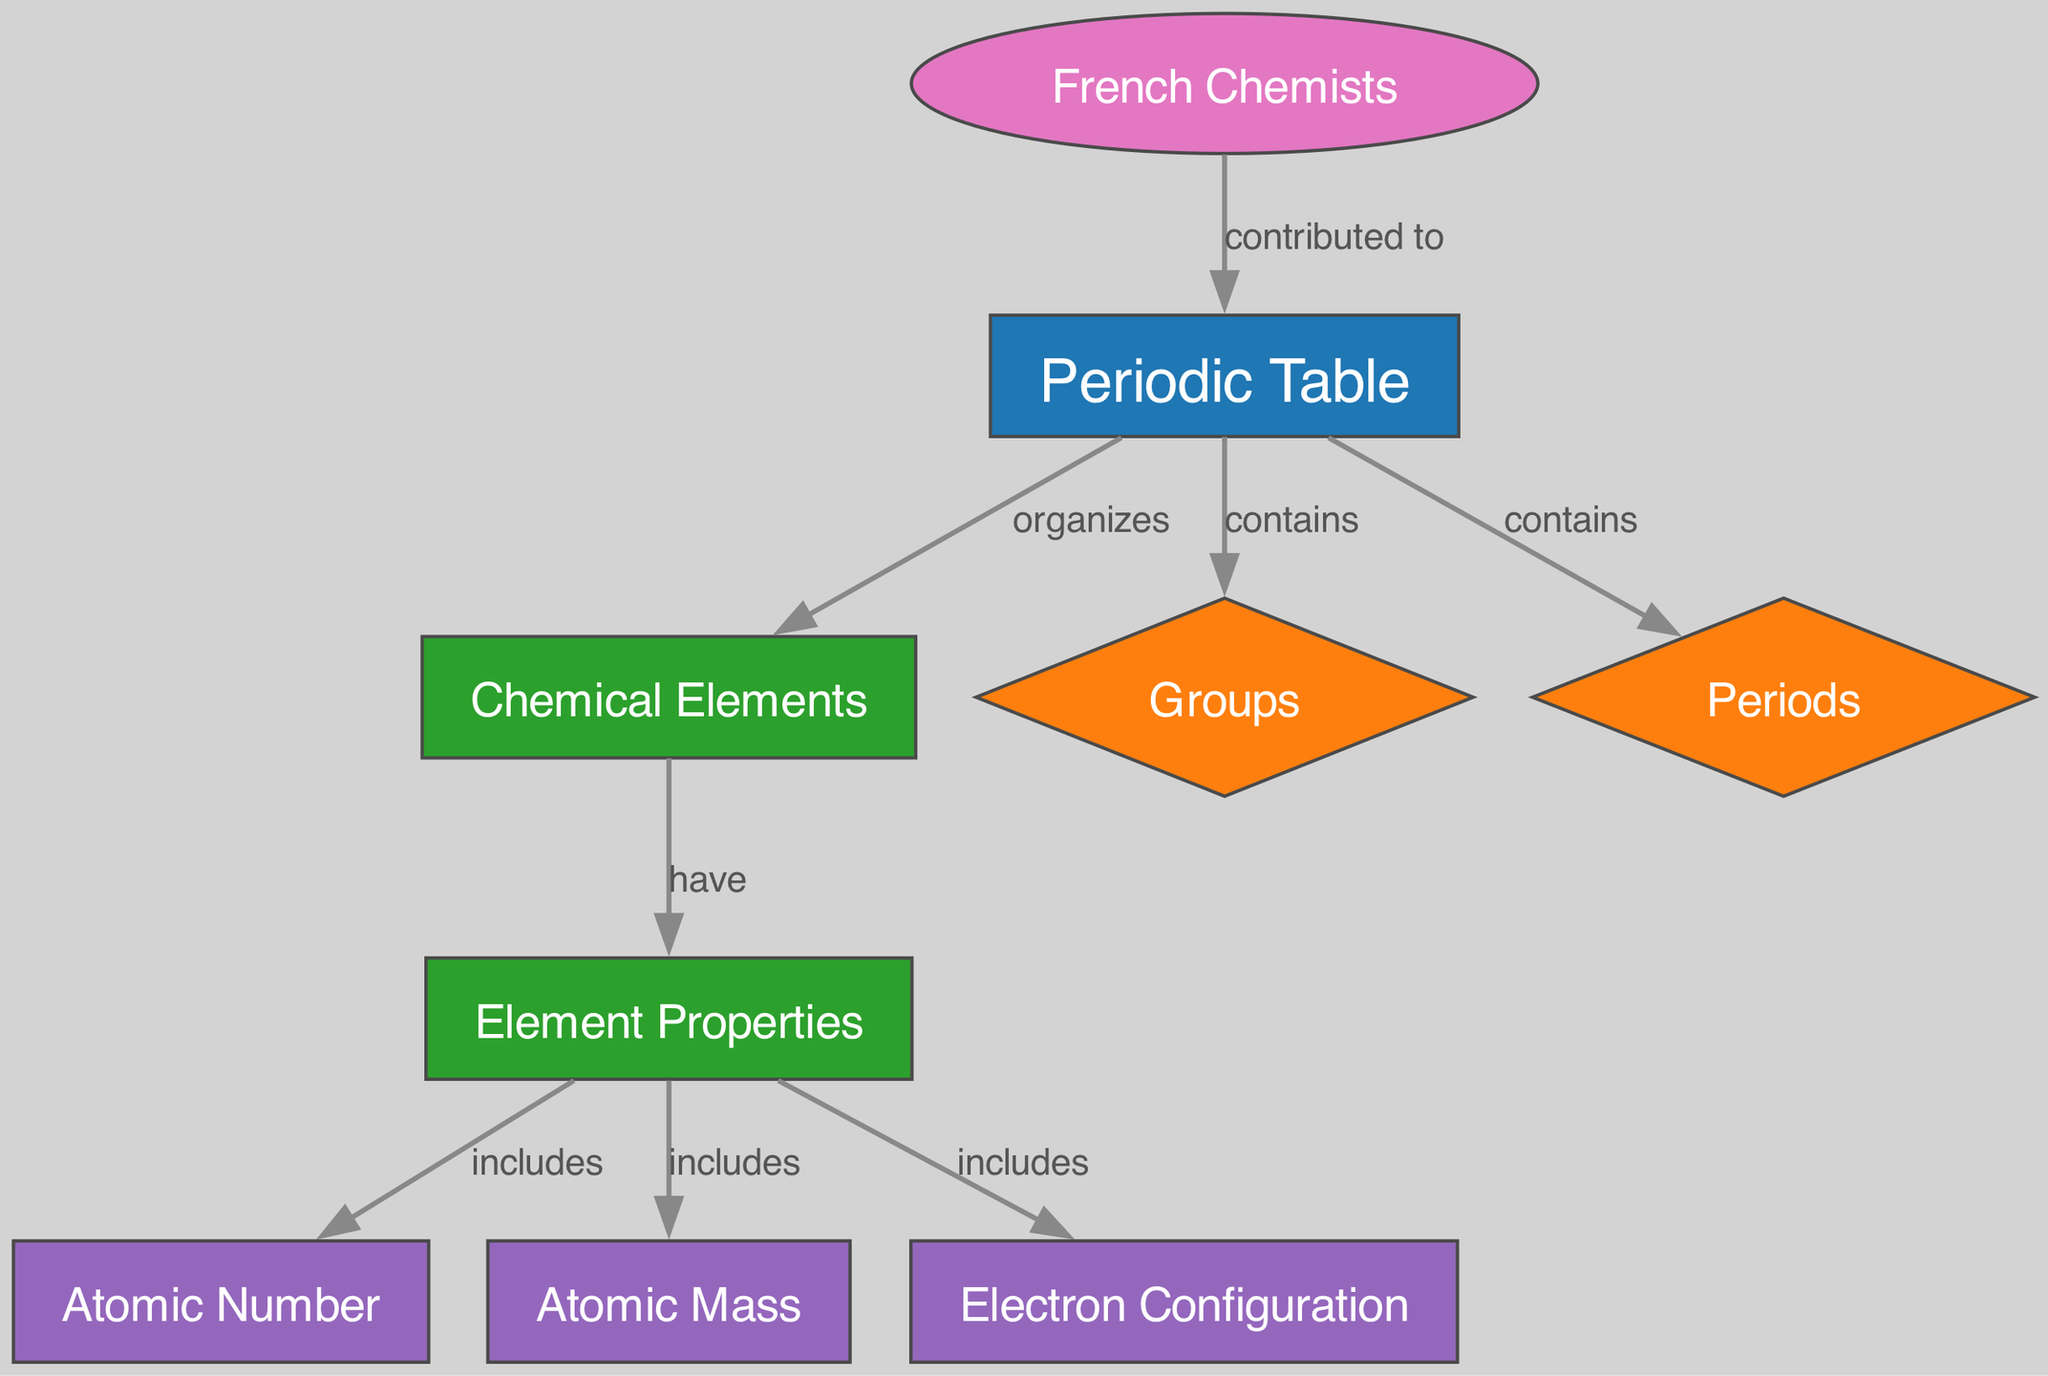What does the periodic table organize? The diagram indicates that the periodic table organizes chemical elements. The relationship is explicitly stated in the edge connecting "periodic_table" to "elements" labeled "organizes."
Answer: chemical elements What types of groups does the periodic table contain? The periodic table contains groups, as mentioned in the edge labeled "contains" connecting "periodic_table" to "groups." This confirms that groups are a category present in the periodic table.
Answer: groups What are three properties included under element properties? The properties include atomic number, atomic mass, and electron configuration. This is derived from the edges connecting "properties" to each of these three attributes labeled "includes."
Answer: atomic number, atomic mass, electron configuration Who contributed to the development of the periodic table? French chemists contributed to the periodic table, as indicated by the edge connecting "french_chemists" to "periodic_table," labeled "contributed to."
Answer: French chemists What is the relationship between elements and properties? The relationship is that elements have properties, as indicated by the edge connecting "elements" to "properties" labeled "have." This shows the fundamental link between these two aspects.
Answer: have How many nodes are present in the diagram? By counting the nodes listed in the diagram, there are a total of nine nodes. This includes all elements represented, such as "periodic_table," "elements," and so on.
Answer: nine What do the periods represent in the periodic table? The periods represent a category within the periodic table as shown by the edge labeled "contains" connecting "periodic_table" to "periods." This indicates that periods classify how the table is organized.
Answer: periods What information does the atomic number provide? The atomic number provides a specific property of chemical elements, as indicated by the edge labeled "includes" connecting "properties" to "atomic_number." This states that it is an essential attribute of elements.
Answer: atomic number 